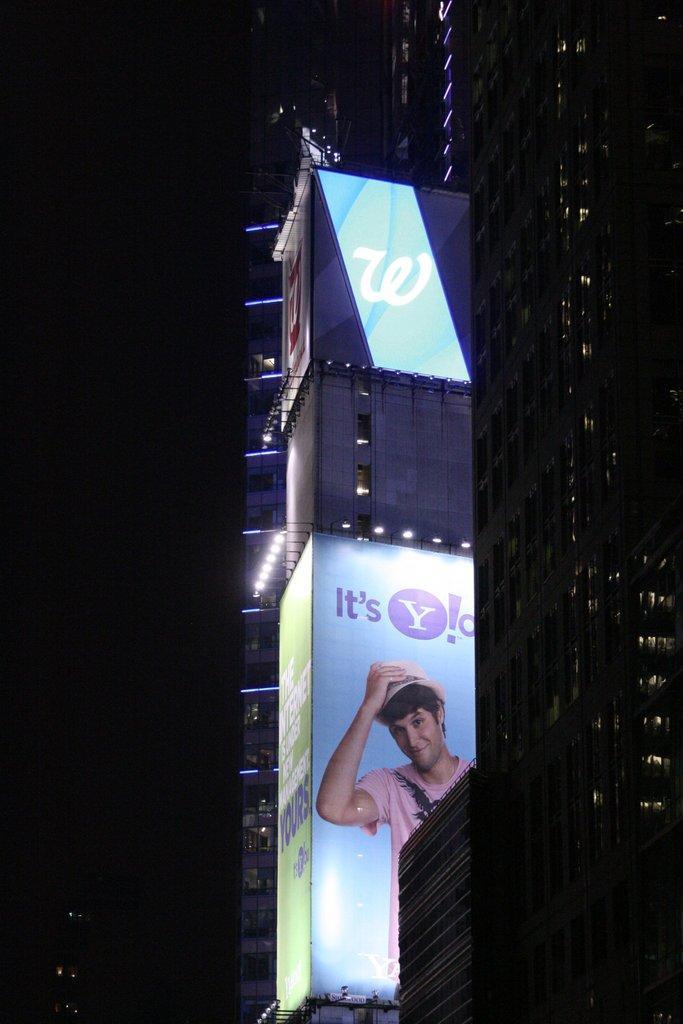Can you describe this image briefly? In this picture I can see the advertisement boards on the building. In that banner I can see the person who is wearing t-shirt and hat. Beside that I can see the lights. On the right I can see the skyscrapers. On the left I can see the darkness. 